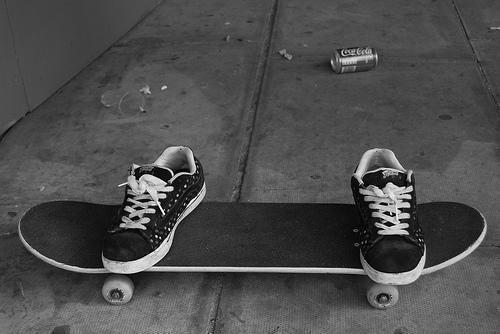How many shoes are there?
Give a very brief answer. 2. How many wheels are visible?
Give a very brief answer. 2. 